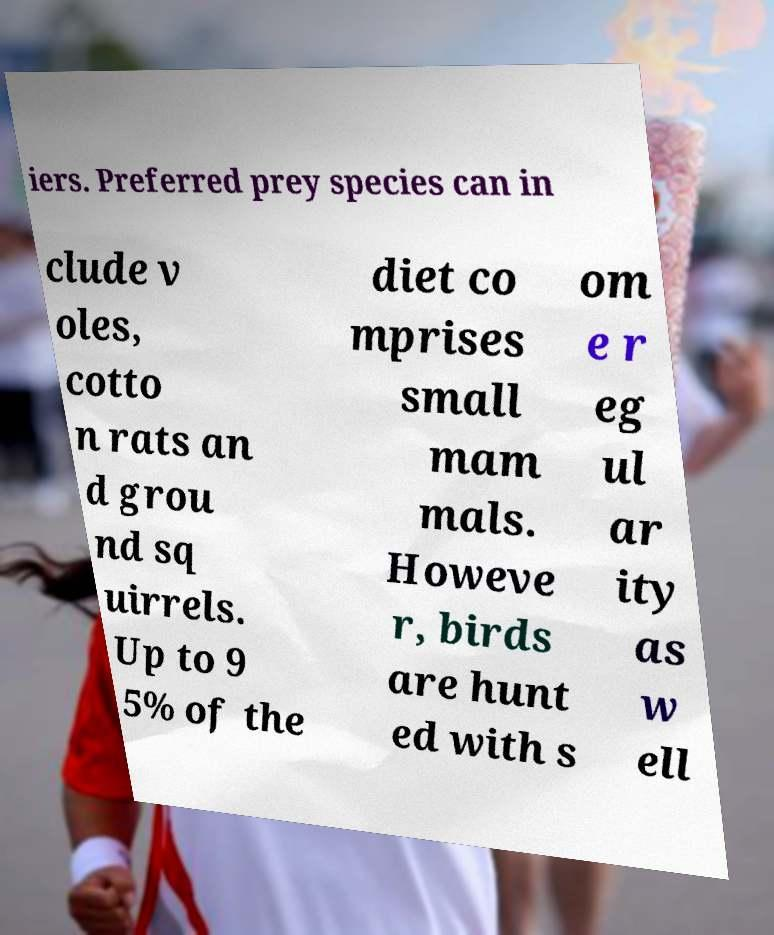There's text embedded in this image that I need extracted. Can you transcribe it verbatim? iers. Preferred prey species can in clude v oles, cotto n rats an d grou nd sq uirrels. Up to 9 5% of the diet co mprises small mam mals. Howeve r, birds are hunt ed with s om e r eg ul ar ity as w ell 